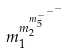Convert formula to latex. <formula><loc_0><loc_0><loc_500><loc_500>m _ { 1 } ^ { m _ { 2 } ^ { m _ { 5 } ^ { - ^ { - ^ { - } } } } }</formula> 